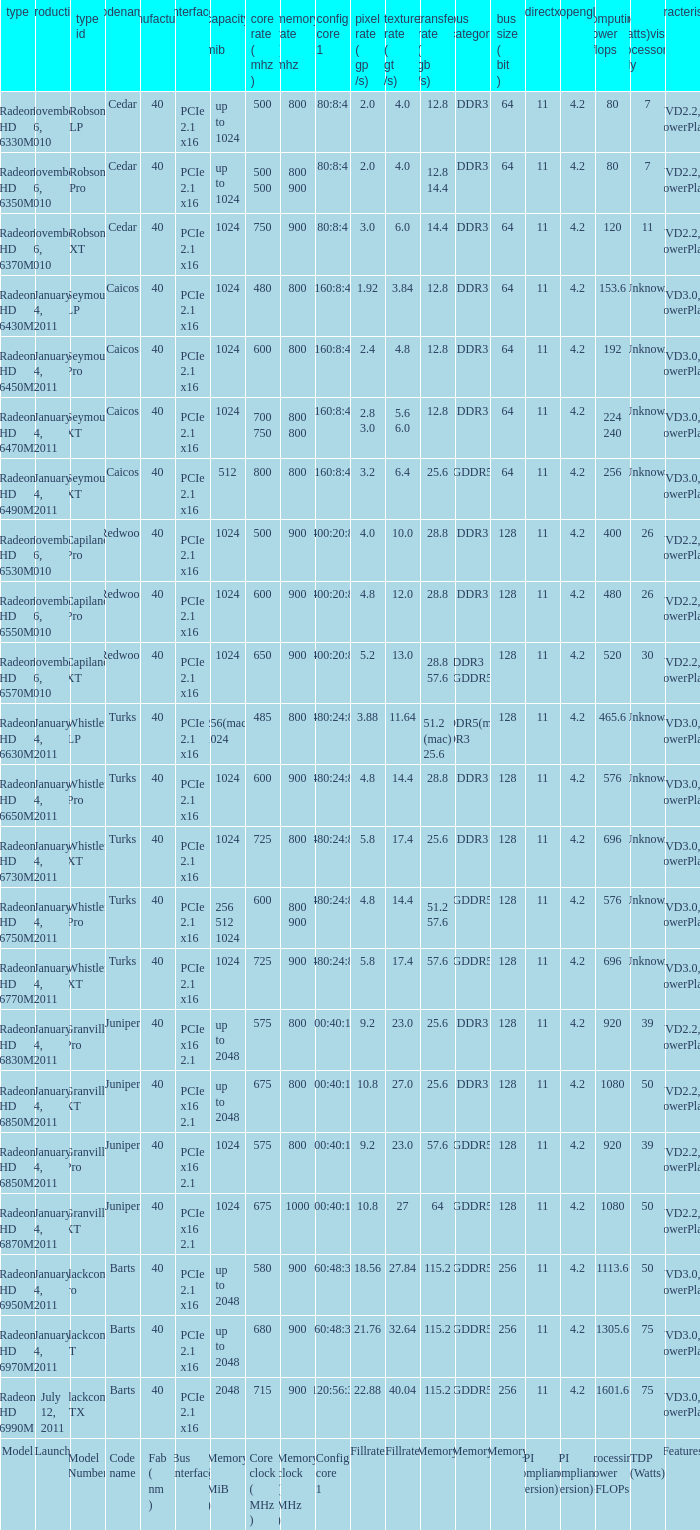What is every code name for the model Radeon HD 6650m? Turks. 